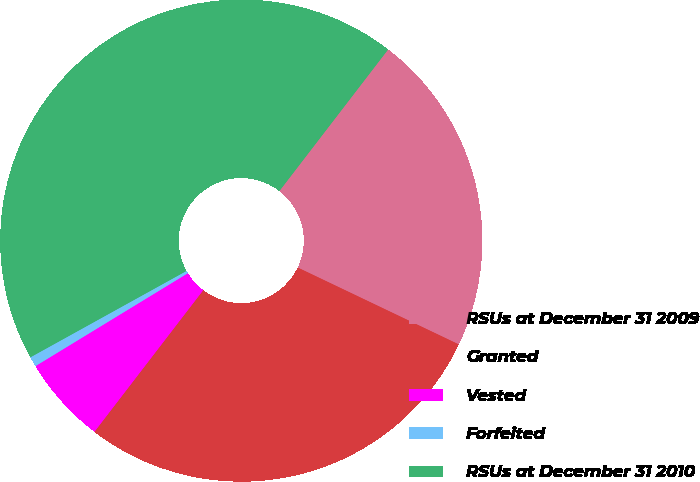<chart> <loc_0><loc_0><loc_500><loc_500><pie_chart><fcel>RSUs at December 31 2009<fcel>Granted<fcel>Vested<fcel>Forfeited<fcel>RSUs at December 31 2010<nl><fcel>21.66%<fcel>28.34%<fcel>5.86%<fcel>0.67%<fcel>43.47%<nl></chart> 